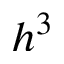<formula> <loc_0><loc_0><loc_500><loc_500>h ^ { 3 }</formula> 